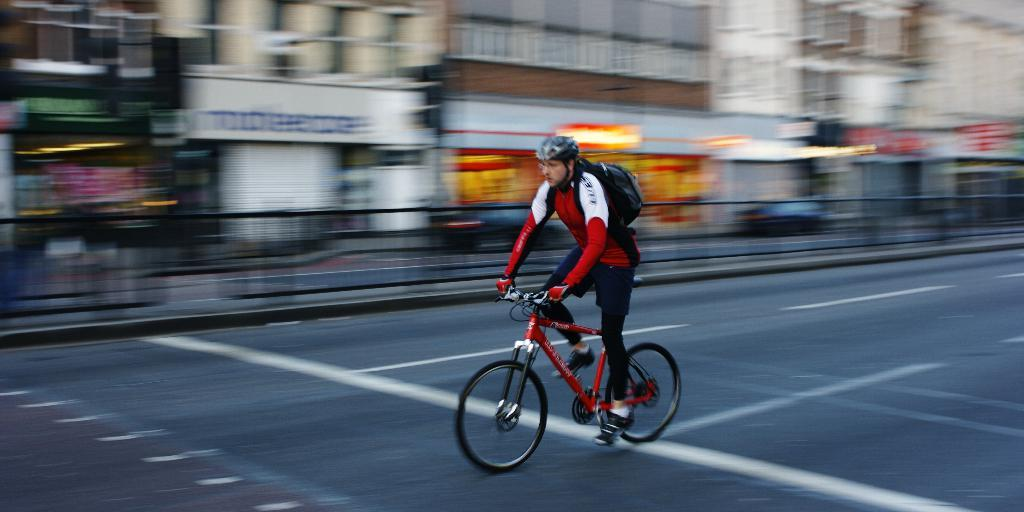What is the man in the image doing? The man is riding a bicycle in the image. What is the man wearing while riding the bicycle? The man is wearing a helmet in the image. What is the man carrying while riding the bicycle? The man is carrying a bag in the image. Where is the bicycle located in the image? The bicycle is on the road in the image. What can be seen in the background of the image? There are buildings, a fence, and some objects in the background of the image. How would you describe the background of the image? The background of the image is blurry. Can you see the queen waving from one of the planes in the background of the image? There are no planes or queens present in the image; it features a man riding a bicycle on the road with a blurry background. 